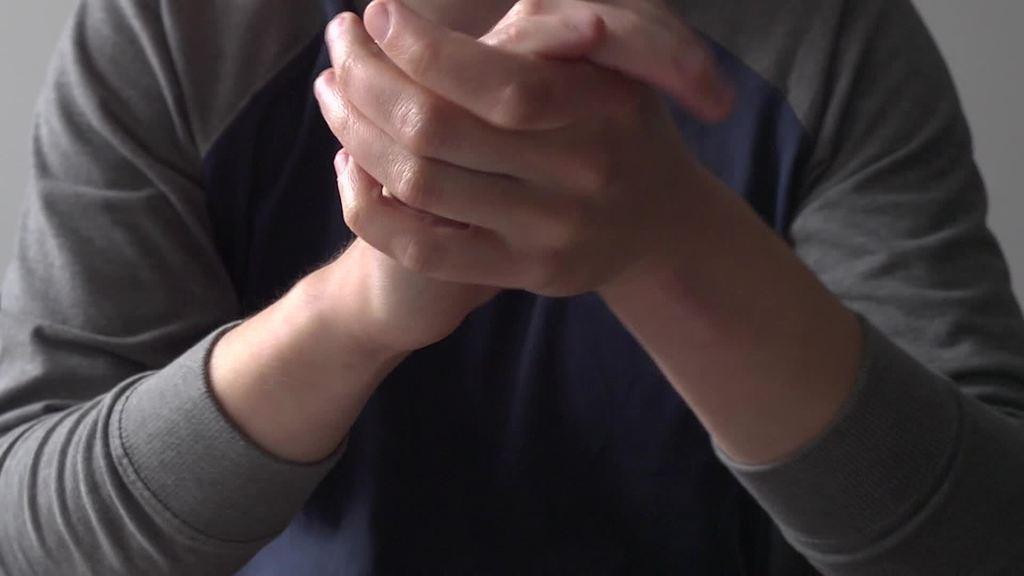Describe this image in one or two sentences. In the center of the image, we can see a person holding hands. 